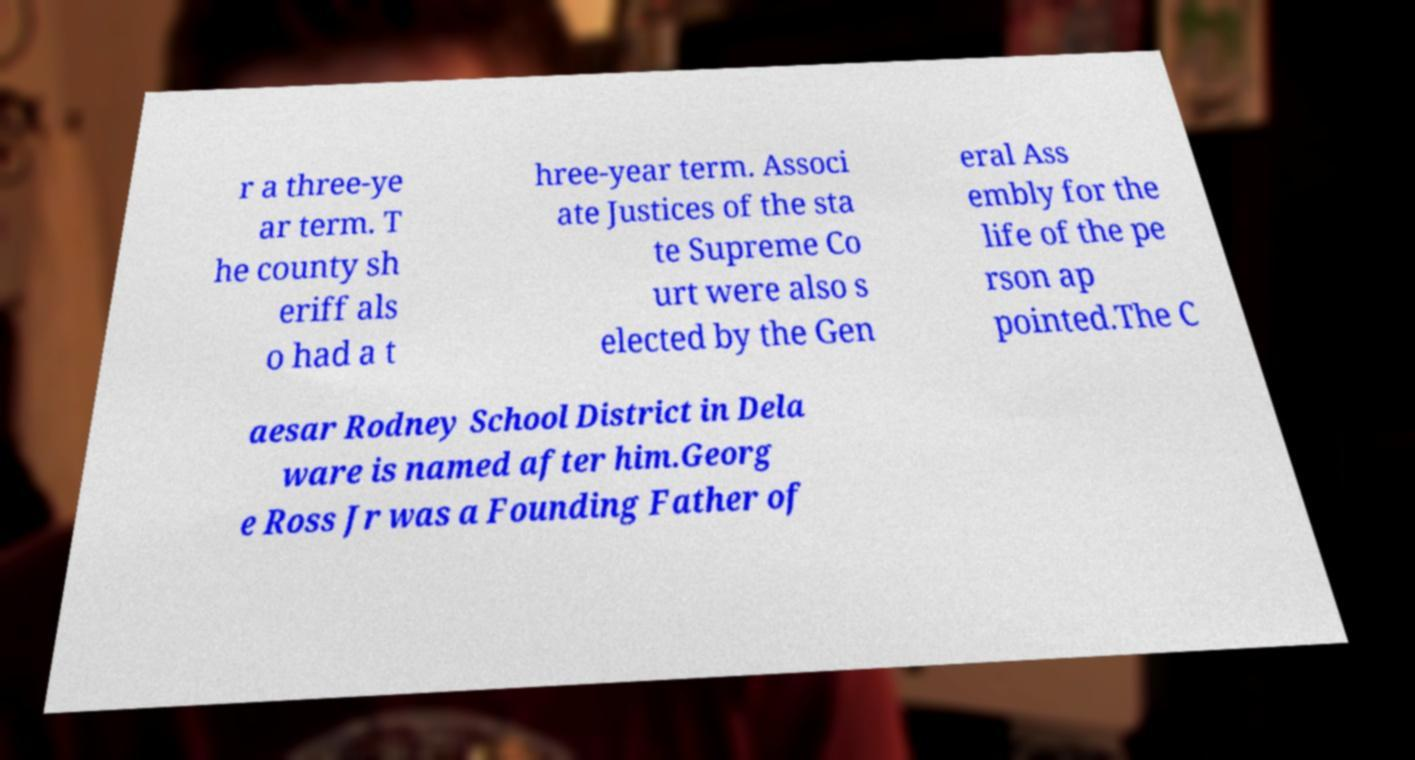Can you read and provide the text displayed in the image?This photo seems to have some interesting text. Can you extract and type it out for me? r a three-ye ar term. T he county sh eriff als o had a t hree-year term. Associ ate Justices of the sta te Supreme Co urt were also s elected by the Gen eral Ass embly for the life of the pe rson ap pointed.The C aesar Rodney School District in Dela ware is named after him.Georg e Ross Jr was a Founding Father of 